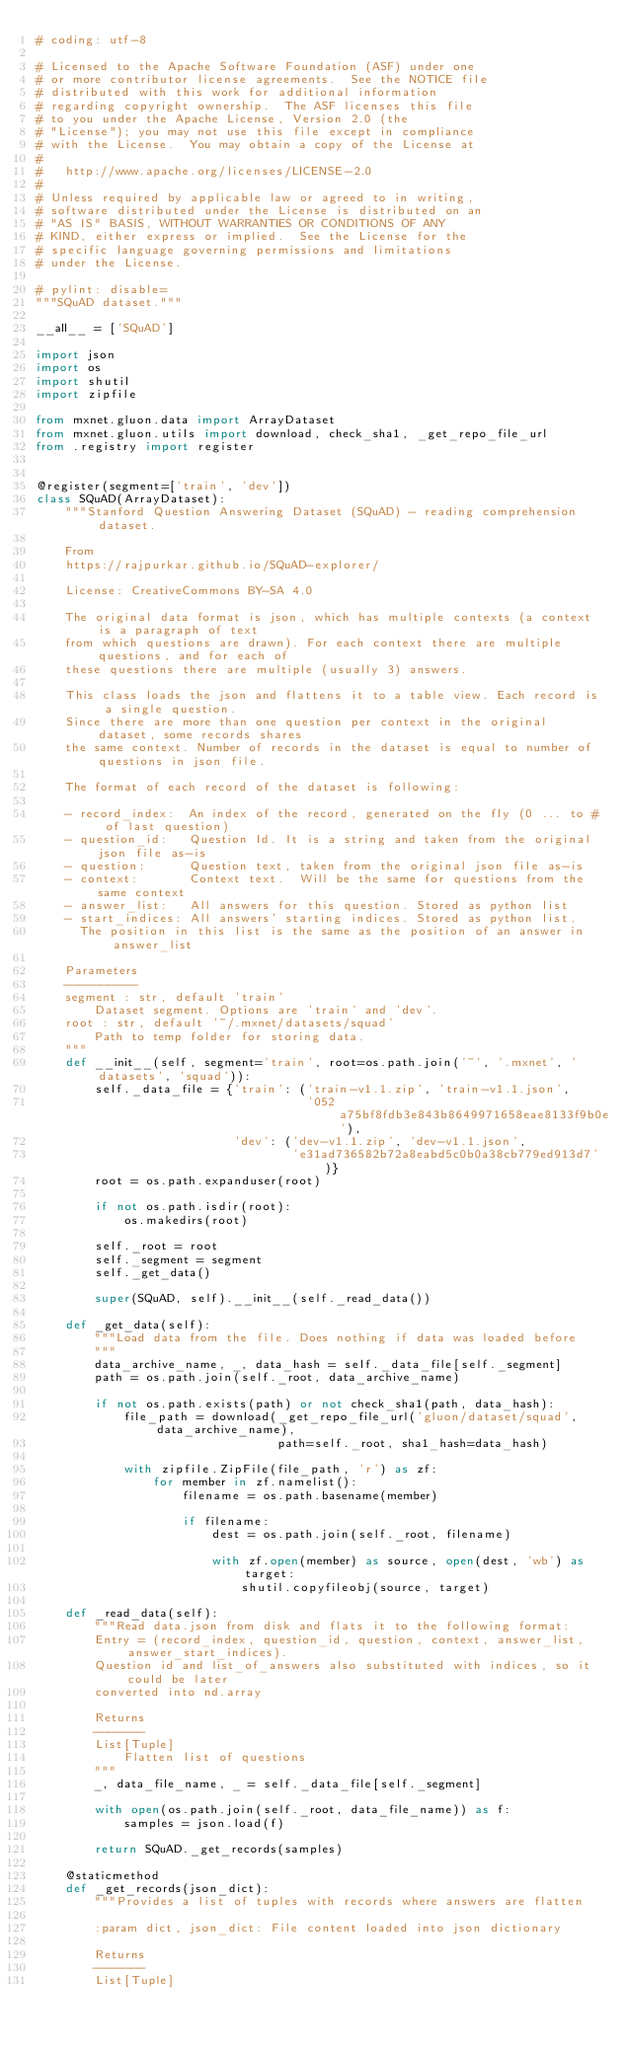Convert code to text. <code><loc_0><loc_0><loc_500><loc_500><_Python_># coding: utf-8

# Licensed to the Apache Software Foundation (ASF) under one
# or more contributor license agreements.  See the NOTICE file
# distributed with this work for additional information
# regarding copyright ownership.  The ASF licenses this file
# to you under the Apache License, Version 2.0 (the
# "License"); you may not use this file except in compliance
# with the License.  You may obtain a copy of the License at
#
#   http://www.apache.org/licenses/LICENSE-2.0
#
# Unless required by applicable law or agreed to in writing,
# software distributed under the License is distributed on an
# "AS IS" BASIS, WITHOUT WARRANTIES OR CONDITIONS OF ANY
# KIND, either express or implied.  See the License for the
# specific language governing permissions and limitations
# under the License.

# pylint: disable=
"""SQuAD dataset."""

__all__ = ['SQuAD']

import json
import os
import shutil
import zipfile

from mxnet.gluon.data import ArrayDataset
from mxnet.gluon.utils import download, check_sha1, _get_repo_file_url
from .registry import register


@register(segment=['train', 'dev'])
class SQuAD(ArrayDataset):
    """Stanford Question Answering Dataset (SQuAD) - reading comprehension dataset.

    From
    https://rajpurkar.github.io/SQuAD-explorer/

    License: CreativeCommons BY-SA 4.0

    The original data format is json, which has multiple contexts (a context is a paragraph of text
    from which questions are drawn). For each context there are multiple questions, and for each of
    these questions there are multiple (usually 3) answers.

    This class loads the json and flattens it to a table view. Each record is a single question.
    Since there are more than one question per context in the original dataset, some records shares
    the same context. Number of records in the dataset is equal to number of questions in json file.

    The format of each record of the dataset is following:

    - record_index:  An index of the record, generated on the fly (0 ... to # of last question)
    - question_id:   Question Id. It is a string and taken from the original json file as-is
    - question:      Question text, taken from the original json file as-is
    - context:       Context text.  Will be the same for questions from the same context
    - answer_list:   All answers for this question. Stored as python list
    - start_indices: All answers' starting indices. Stored as python list.
      The position in this list is the same as the position of an answer in answer_list

    Parameters
    ----------
    segment : str, default 'train'
        Dataset segment. Options are 'train' and 'dev'.
    root : str, default '~/.mxnet/datasets/squad'
        Path to temp folder for storing data.
    """
    def __init__(self, segment='train', root=os.path.join('~', '.mxnet', 'datasets', 'squad')):
        self._data_file = {'train': ('train-v1.1.zip', 'train-v1.1.json',
                                     '052a75bf8fdb3e843b8649971658eae8133f9b0e'),
                           'dev': ('dev-v1.1.zip', 'dev-v1.1.json',
                                   'e31ad736582b72a8eabd5c0b0a38cb779ed913d7')}
        root = os.path.expanduser(root)

        if not os.path.isdir(root):
            os.makedirs(root)

        self._root = root
        self._segment = segment
        self._get_data()

        super(SQuAD, self).__init__(self._read_data())

    def _get_data(self):
        """Load data from the file. Does nothing if data was loaded before
        """
        data_archive_name, _, data_hash = self._data_file[self._segment]
        path = os.path.join(self._root, data_archive_name)

        if not os.path.exists(path) or not check_sha1(path, data_hash):
            file_path = download(_get_repo_file_url('gluon/dataset/squad', data_archive_name),
                                 path=self._root, sha1_hash=data_hash)

            with zipfile.ZipFile(file_path, 'r') as zf:
                for member in zf.namelist():
                    filename = os.path.basename(member)

                    if filename:
                        dest = os.path.join(self._root, filename)

                        with zf.open(member) as source, open(dest, 'wb') as target:
                            shutil.copyfileobj(source, target)

    def _read_data(self):
        """Read data.json from disk and flats it to the following format:
        Entry = (record_index, question_id, question, context, answer_list, answer_start_indices).
        Question id and list_of_answers also substituted with indices, so it could be later
        converted into nd.array

        Returns
        -------
        List[Tuple]
            Flatten list of questions
        """
        _, data_file_name, _ = self._data_file[self._segment]

        with open(os.path.join(self._root, data_file_name)) as f:
            samples = json.load(f)

        return SQuAD._get_records(samples)

    @staticmethod
    def _get_records(json_dict):
        """Provides a list of tuples with records where answers are flatten

        :param dict, json_dict: File content loaded into json dictionary

        Returns
        -------
        List[Tuple]</code> 